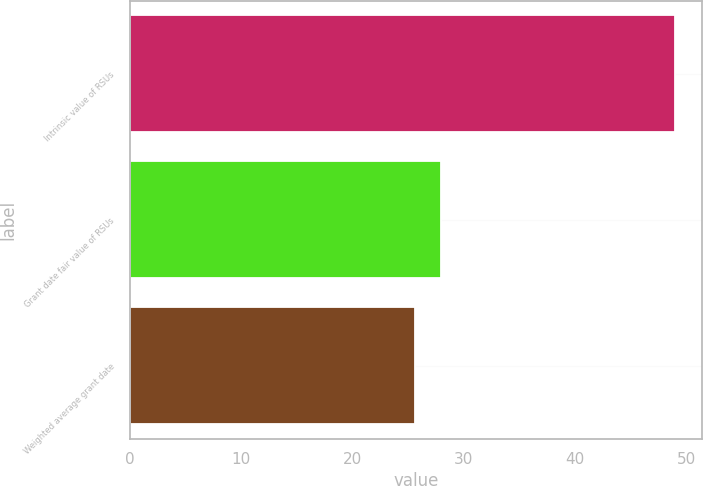<chart> <loc_0><loc_0><loc_500><loc_500><bar_chart><fcel>Intrinsic value of RSUs<fcel>Grant date fair value of RSUs<fcel>Weighted average grant date<nl><fcel>49<fcel>28<fcel>25.64<nl></chart> 